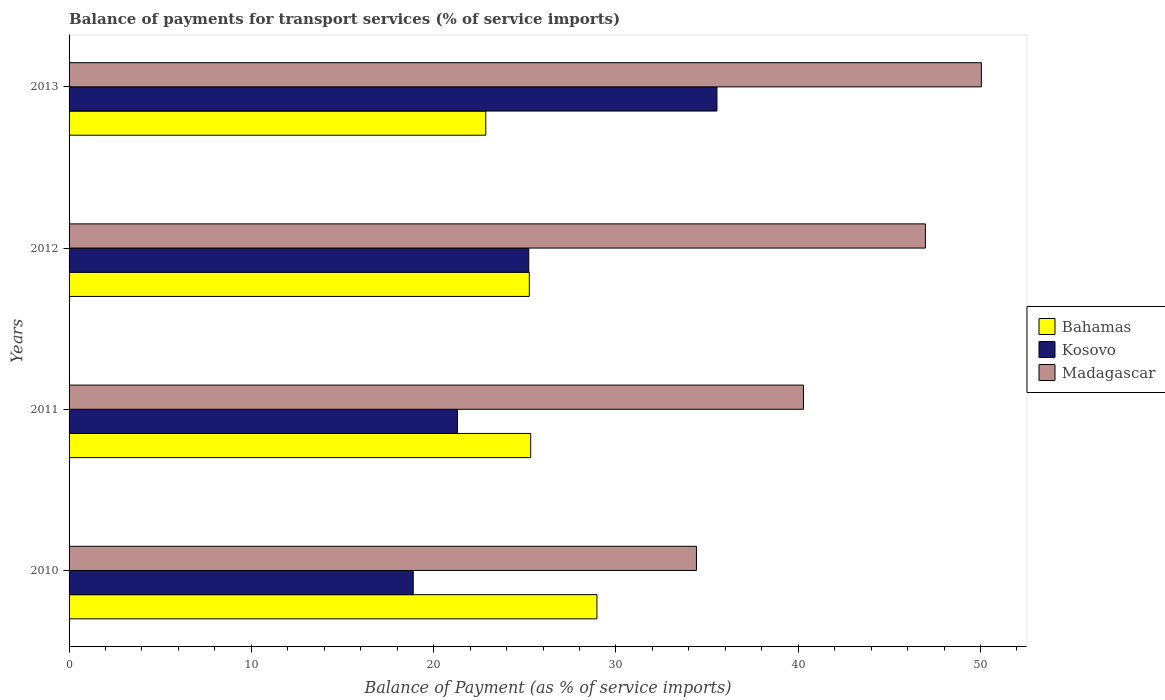How many groups of bars are there?
Ensure brevity in your answer.  4. Are the number of bars on each tick of the Y-axis equal?
Provide a succinct answer. Yes. What is the label of the 1st group of bars from the top?
Offer a very short reply. 2013. In how many cases, is the number of bars for a given year not equal to the number of legend labels?
Your answer should be compact. 0. What is the balance of payments for transport services in Bahamas in 2010?
Your answer should be compact. 28.96. Across all years, what is the maximum balance of payments for transport services in Madagascar?
Provide a succinct answer. 50.05. Across all years, what is the minimum balance of payments for transport services in Madagascar?
Give a very brief answer. 34.42. In which year was the balance of payments for transport services in Kosovo maximum?
Make the answer very short. 2013. What is the total balance of payments for transport services in Kosovo in the graph?
Your response must be concise. 100.95. What is the difference between the balance of payments for transport services in Bahamas in 2010 and that in 2012?
Your answer should be compact. 3.71. What is the difference between the balance of payments for transport services in Kosovo in 2011 and the balance of payments for transport services in Bahamas in 2013?
Offer a terse response. -1.55. What is the average balance of payments for transport services in Kosovo per year?
Your response must be concise. 25.24. In the year 2010, what is the difference between the balance of payments for transport services in Kosovo and balance of payments for transport services in Bahamas?
Provide a short and direct response. -10.08. In how many years, is the balance of payments for transport services in Kosovo greater than 2 %?
Your answer should be compact. 4. What is the ratio of the balance of payments for transport services in Madagascar in 2011 to that in 2013?
Keep it short and to the point. 0.8. Is the balance of payments for transport services in Bahamas in 2012 less than that in 2013?
Give a very brief answer. No. What is the difference between the highest and the second highest balance of payments for transport services in Madagascar?
Your answer should be compact. 3.07. What is the difference between the highest and the lowest balance of payments for transport services in Kosovo?
Provide a succinct answer. 16.66. In how many years, is the balance of payments for transport services in Bahamas greater than the average balance of payments for transport services in Bahamas taken over all years?
Make the answer very short. 1. What does the 1st bar from the top in 2010 represents?
Make the answer very short. Madagascar. What does the 1st bar from the bottom in 2011 represents?
Your answer should be very brief. Bahamas. Is it the case that in every year, the sum of the balance of payments for transport services in Madagascar and balance of payments for transport services in Bahamas is greater than the balance of payments for transport services in Kosovo?
Make the answer very short. Yes. How many years are there in the graph?
Provide a succinct answer. 4. How are the legend labels stacked?
Keep it short and to the point. Vertical. What is the title of the graph?
Your answer should be very brief. Balance of payments for transport services (% of service imports). What is the label or title of the X-axis?
Your answer should be compact. Balance of Payment (as % of service imports). What is the Balance of Payment (as % of service imports) of Bahamas in 2010?
Your answer should be very brief. 28.96. What is the Balance of Payment (as % of service imports) of Kosovo in 2010?
Ensure brevity in your answer.  18.88. What is the Balance of Payment (as % of service imports) in Madagascar in 2010?
Make the answer very short. 34.42. What is the Balance of Payment (as % of service imports) of Bahamas in 2011?
Make the answer very short. 25.32. What is the Balance of Payment (as % of service imports) in Kosovo in 2011?
Offer a terse response. 21.31. What is the Balance of Payment (as % of service imports) in Madagascar in 2011?
Offer a terse response. 40.29. What is the Balance of Payment (as % of service imports) of Bahamas in 2012?
Offer a very short reply. 25.25. What is the Balance of Payment (as % of service imports) of Kosovo in 2012?
Your response must be concise. 25.22. What is the Balance of Payment (as % of service imports) in Madagascar in 2012?
Your response must be concise. 46.98. What is the Balance of Payment (as % of service imports) in Bahamas in 2013?
Your answer should be compact. 22.86. What is the Balance of Payment (as % of service imports) in Kosovo in 2013?
Ensure brevity in your answer.  35.54. What is the Balance of Payment (as % of service imports) of Madagascar in 2013?
Give a very brief answer. 50.05. Across all years, what is the maximum Balance of Payment (as % of service imports) in Bahamas?
Your answer should be very brief. 28.96. Across all years, what is the maximum Balance of Payment (as % of service imports) of Kosovo?
Your answer should be very brief. 35.54. Across all years, what is the maximum Balance of Payment (as % of service imports) in Madagascar?
Ensure brevity in your answer.  50.05. Across all years, what is the minimum Balance of Payment (as % of service imports) of Bahamas?
Your response must be concise. 22.86. Across all years, what is the minimum Balance of Payment (as % of service imports) of Kosovo?
Offer a very short reply. 18.88. Across all years, what is the minimum Balance of Payment (as % of service imports) of Madagascar?
Ensure brevity in your answer.  34.42. What is the total Balance of Payment (as % of service imports) in Bahamas in the graph?
Your answer should be compact. 102.39. What is the total Balance of Payment (as % of service imports) in Kosovo in the graph?
Offer a very short reply. 100.95. What is the total Balance of Payment (as % of service imports) in Madagascar in the graph?
Provide a short and direct response. 171.73. What is the difference between the Balance of Payment (as % of service imports) of Bahamas in 2010 and that in 2011?
Provide a succinct answer. 3.63. What is the difference between the Balance of Payment (as % of service imports) of Kosovo in 2010 and that in 2011?
Make the answer very short. -2.43. What is the difference between the Balance of Payment (as % of service imports) of Madagascar in 2010 and that in 2011?
Offer a very short reply. -5.87. What is the difference between the Balance of Payment (as % of service imports) of Bahamas in 2010 and that in 2012?
Provide a succinct answer. 3.71. What is the difference between the Balance of Payment (as % of service imports) of Kosovo in 2010 and that in 2012?
Ensure brevity in your answer.  -6.34. What is the difference between the Balance of Payment (as % of service imports) of Madagascar in 2010 and that in 2012?
Make the answer very short. -12.56. What is the difference between the Balance of Payment (as % of service imports) in Bahamas in 2010 and that in 2013?
Provide a short and direct response. 6.1. What is the difference between the Balance of Payment (as % of service imports) of Kosovo in 2010 and that in 2013?
Offer a very short reply. -16.66. What is the difference between the Balance of Payment (as % of service imports) in Madagascar in 2010 and that in 2013?
Offer a terse response. -15.63. What is the difference between the Balance of Payment (as % of service imports) of Bahamas in 2011 and that in 2012?
Your response must be concise. 0.08. What is the difference between the Balance of Payment (as % of service imports) in Kosovo in 2011 and that in 2012?
Provide a succinct answer. -3.91. What is the difference between the Balance of Payment (as % of service imports) in Madagascar in 2011 and that in 2012?
Give a very brief answer. -6.69. What is the difference between the Balance of Payment (as % of service imports) in Bahamas in 2011 and that in 2013?
Your answer should be very brief. 2.46. What is the difference between the Balance of Payment (as % of service imports) of Kosovo in 2011 and that in 2013?
Provide a succinct answer. -14.23. What is the difference between the Balance of Payment (as % of service imports) of Madagascar in 2011 and that in 2013?
Your answer should be compact. -9.76. What is the difference between the Balance of Payment (as % of service imports) of Bahamas in 2012 and that in 2013?
Keep it short and to the point. 2.39. What is the difference between the Balance of Payment (as % of service imports) in Kosovo in 2012 and that in 2013?
Your answer should be compact. -10.32. What is the difference between the Balance of Payment (as % of service imports) of Madagascar in 2012 and that in 2013?
Your answer should be compact. -3.07. What is the difference between the Balance of Payment (as % of service imports) of Bahamas in 2010 and the Balance of Payment (as % of service imports) of Kosovo in 2011?
Offer a terse response. 7.65. What is the difference between the Balance of Payment (as % of service imports) of Bahamas in 2010 and the Balance of Payment (as % of service imports) of Madagascar in 2011?
Ensure brevity in your answer.  -11.33. What is the difference between the Balance of Payment (as % of service imports) in Kosovo in 2010 and the Balance of Payment (as % of service imports) in Madagascar in 2011?
Ensure brevity in your answer.  -21.41. What is the difference between the Balance of Payment (as % of service imports) of Bahamas in 2010 and the Balance of Payment (as % of service imports) of Kosovo in 2012?
Your response must be concise. 3.74. What is the difference between the Balance of Payment (as % of service imports) in Bahamas in 2010 and the Balance of Payment (as % of service imports) in Madagascar in 2012?
Offer a terse response. -18.02. What is the difference between the Balance of Payment (as % of service imports) of Kosovo in 2010 and the Balance of Payment (as % of service imports) of Madagascar in 2012?
Your answer should be very brief. -28.1. What is the difference between the Balance of Payment (as % of service imports) of Bahamas in 2010 and the Balance of Payment (as % of service imports) of Kosovo in 2013?
Make the answer very short. -6.58. What is the difference between the Balance of Payment (as % of service imports) in Bahamas in 2010 and the Balance of Payment (as % of service imports) in Madagascar in 2013?
Your response must be concise. -21.09. What is the difference between the Balance of Payment (as % of service imports) in Kosovo in 2010 and the Balance of Payment (as % of service imports) in Madagascar in 2013?
Your answer should be very brief. -31.17. What is the difference between the Balance of Payment (as % of service imports) of Bahamas in 2011 and the Balance of Payment (as % of service imports) of Kosovo in 2012?
Offer a very short reply. 0.11. What is the difference between the Balance of Payment (as % of service imports) in Bahamas in 2011 and the Balance of Payment (as % of service imports) in Madagascar in 2012?
Keep it short and to the point. -21.65. What is the difference between the Balance of Payment (as % of service imports) of Kosovo in 2011 and the Balance of Payment (as % of service imports) of Madagascar in 2012?
Give a very brief answer. -25.67. What is the difference between the Balance of Payment (as % of service imports) of Bahamas in 2011 and the Balance of Payment (as % of service imports) of Kosovo in 2013?
Make the answer very short. -10.22. What is the difference between the Balance of Payment (as % of service imports) of Bahamas in 2011 and the Balance of Payment (as % of service imports) of Madagascar in 2013?
Provide a short and direct response. -24.72. What is the difference between the Balance of Payment (as % of service imports) in Kosovo in 2011 and the Balance of Payment (as % of service imports) in Madagascar in 2013?
Provide a short and direct response. -28.74. What is the difference between the Balance of Payment (as % of service imports) in Bahamas in 2012 and the Balance of Payment (as % of service imports) in Kosovo in 2013?
Provide a succinct answer. -10.29. What is the difference between the Balance of Payment (as % of service imports) in Bahamas in 2012 and the Balance of Payment (as % of service imports) in Madagascar in 2013?
Offer a terse response. -24.8. What is the difference between the Balance of Payment (as % of service imports) in Kosovo in 2012 and the Balance of Payment (as % of service imports) in Madagascar in 2013?
Your answer should be compact. -24.83. What is the average Balance of Payment (as % of service imports) of Bahamas per year?
Provide a succinct answer. 25.6. What is the average Balance of Payment (as % of service imports) in Kosovo per year?
Give a very brief answer. 25.24. What is the average Balance of Payment (as % of service imports) of Madagascar per year?
Your answer should be compact. 42.93. In the year 2010, what is the difference between the Balance of Payment (as % of service imports) of Bahamas and Balance of Payment (as % of service imports) of Kosovo?
Provide a short and direct response. 10.08. In the year 2010, what is the difference between the Balance of Payment (as % of service imports) of Bahamas and Balance of Payment (as % of service imports) of Madagascar?
Give a very brief answer. -5.46. In the year 2010, what is the difference between the Balance of Payment (as % of service imports) of Kosovo and Balance of Payment (as % of service imports) of Madagascar?
Provide a short and direct response. -15.54. In the year 2011, what is the difference between the Balance of Payment (as % of service imports) of Bahamas and Balance of Payment (as % of service imports) of Kosovo?
Provide a short and direct response. 4.02. In the year 2011, what is the difference between the Balance of Payment (as % of service imports) in Bahamas and Balance of Payment (as % of service imports) in Madagascar?
Provide a succinct answer. -14.96. In the year 2011, what is the difference between the Balance of Payment (as % of service imports) of Kosovo and Balance of Payment (as % of service imports) of Madagascar?
Offer a very short reply. -18.98. In the year 2012, what is the difference between the Balance of Payment (as % of service imports) of Bahamas and Balance of Payment (as % of service imports) of Kosovo?
Your answer should be very brief. 0.03. In the year 2012, what is the difference between the Balance of Payment (as % of service imports) of Bahamas and Balance of Payment (as % of service imports) of Madagascar?
Keep it short and to the point. -21.73. In the year 2012, what is the difference between the Balance of Payment (as % of service imports) in Kosovo and Balance of Payment (as % of service imports) in Madagascar?
Give a very brief answer. -21.76. In the year 2013, what is the difference between the Balance of Payment (as % of service imports) of Bahamas and Balance of Payment (as % of service imports) of Kosovo?
Offer a terse response. -12.68. In the year 2013, what is the difference between the Balance of Payment (as % of service imports) of Bahamas and Balance of Payment (as % of service imports) of Madagascar?
Your response must be concise. -27.19. In the year 2013, what is the difference between the Balance of Payment (as % of service imports) in Kosovo and Balance of Payment (as % of service imports) in Madagascar?
Keep it short and to the point. -14.51. What is the ratio of the Balance of Payment (as % of service imports) in Bahamas in 2010 to that in 2011?
Ensure brevity in your answer.  1.14. What is the ratio of the Balance of Payment (as % of service imports) of Kosovo in 2010 to that in 2011?
Your answer should be compact. 0.89. What is the ratio of the Balance of Payment (as % of service imports) of Madagascar in 2010 to that in 2011?
Ensure brevity in your answer.  0.85. What is the ratio of the Balance of Payment (as % of service imports) of Bahamas in 2010 to that in 2012?
Offer a very short reply. 1.15. What is the ratio of the Balance of Payment (as % of service imports) of Kosovo in 2010 to that in 2012?
Offer a terse response. 0.75. What is the ratio of the Balance of Payment (as % of service imports) of Madagascar in 2010 to that in 2012?
Ensure brevity in your answer.  0.73. What is the ratio of the Balance of Payment (as % of service imports) of Bahamas in 2010 to that in 2013?
Offer a very short reply. 1.27. What is the ratio of the Balance of Payment (as % of service imports) of Kosovo in 2010 to that in 2013?
Provide a short and direct response. 0.53. What is the ratio of the Balance of Payment (as % of service imports) of Madagascar in 2010 to that in 2013?
Give a very brief answer. 0.69. What is the ratio of the Balance of Payment (as % of service imports) of Kosovo in 2011 to that in 2012?
Your answer should be compact. 0.84. What is the ratio of the Balance of Payment (as % of service imports) of Madagascar in 2011 to that in 2012?
Provide a short and direct response. 0.86. What is the ratio of the Balance of Payment (as % of service imports) of Bahamas in 2011 to that in 2013?
Offer a very short reply. 1.11. What is the ratio of the Balance of Payment (as % of service imports) in Kosovo in 2011 to that in 2013?
Keep it short and to the point. 0.6. What is the ratio of the Balance of Payment (as % of service imports) in Madagascar in 2011 to that in 2013?
Make the answer very short. 0.81. What is the ratio of the Balance of Payment (as % of service imports) in Bahamas in 2012 to that in 2013?
Make the answer very short. 1.1. What is the ratio of the Balance of Payment (as % of service imports) in Kosovo in 2012 to that in 2013?
Your answer should be very brief. 0.71. What is the ratio of the Balance of Payment (as % of service imports) in Madagascar in 2012 to that in 2013?
Your answer should be very brief. 0.94. What is the difference between the highest and the second highest Balance of Payment (as % of service imports) of Bahamas?
Your answer should be compact. 3.63. What is the difference between the highest and the second highest Balance of Payment (as % of service imports) of Kosovo?
Give a very brief answer. 10.32. What is the difference between the highest and the second highest Balance of Payment (as % of service imports) in Madagascar?
Your answer should be compact. 3.07. What is the difference between the highest and the lowest Balance of Payment (as % of service imports) of Bahamas?
Offer a very short reply. 6.1. What is the difference between the highest and the lowest Balance of Payment (as % of service imports) of Kosovo?
Make the answer very short. 16.66. What is the difference between the highest and the lowest Balance of Payment (as % of service imports) of Madagascar?
Your answer should be very brief. 15.63. 